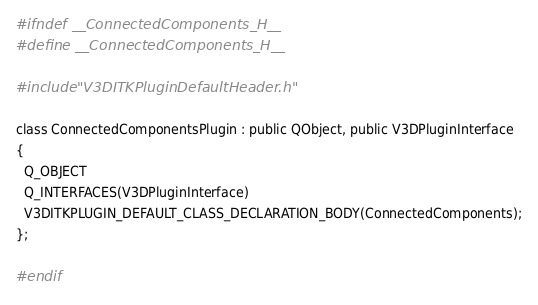Convert code to text. <code><loc_0><loc_0><loc_500><loc_500><_C_>#ifndef __ConnectedComponents_H__
#define __ConnectedComponents_H__

#include "V3DITKPluginDefaultHeader.h"

class ConnectedComponentsPlugin : public QObject, public V3DPluginInterface
{
  Q_OBJECT
  Q_INTERFACES(V3DPluginInterface)
  V3DITKPLUGIN_DEFAULT_CLASS_DECLARATION_BODY(ConnectedComponents);
};

#endif
</code> 